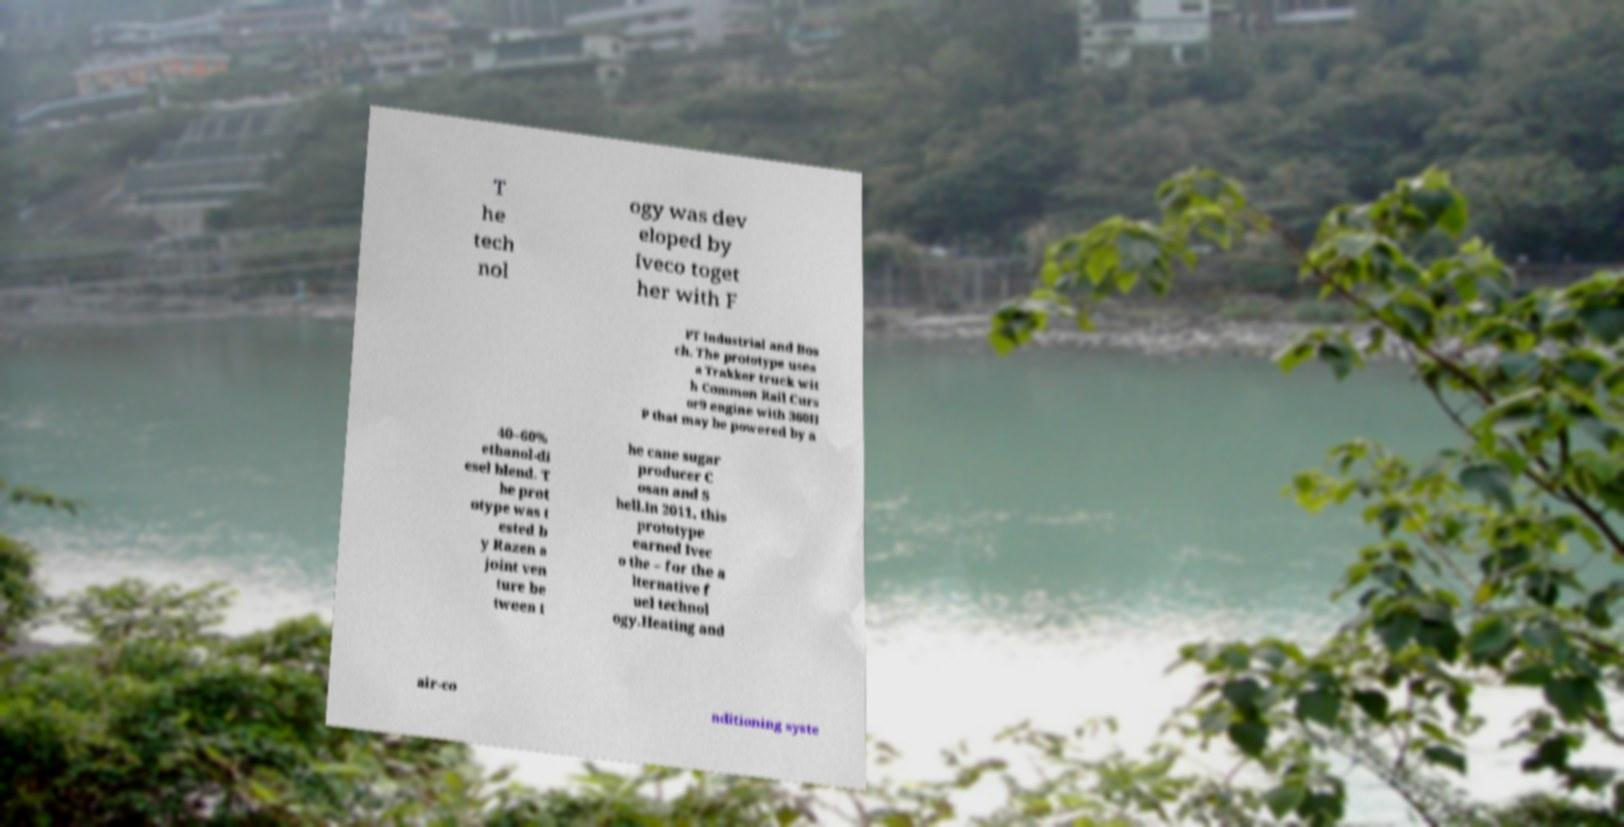Can you accurately transcribe the text from the provided image for me? T he tech nol ogy was dev eloped by Iveco toget her with F PT Industrial and Bos ch. The prototype uses a Trakker truck wit h Common Rail Curs or9 engine with 360H P that may be powered by a 40–60% ethanol-di esel blend. T he prot otype was t ested b y Razen a joint ven ture be tween t he cane sugar producer C osan and S hell.In 2011, this prototype earned Ivec o the – for the a lternative f uel technol ogy.Heating and air-co nditioning syste 